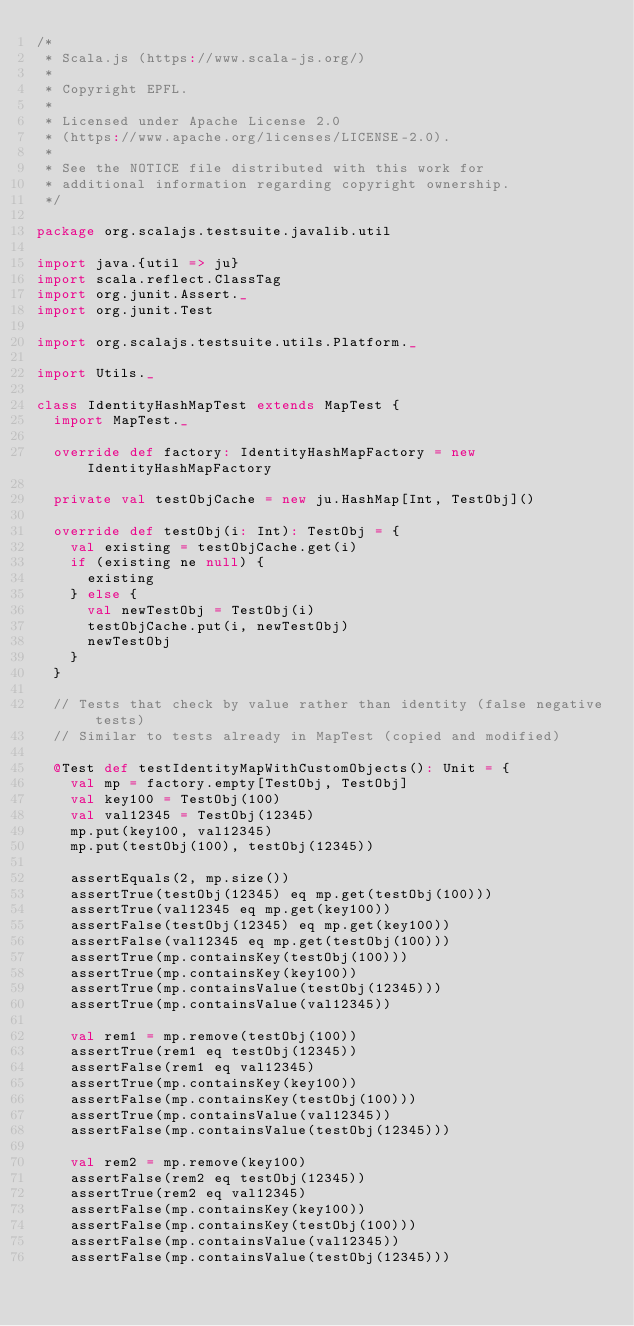<code> <loc_0><loc_0><loc_500><loc_500><_Scala_>/*
 * Scala.js (https://www.scala-js.org/)
 *
 * Copyright EPFL.
 *
 * Licensed under Apache License 2.0
 * (https://www.apache.org/licenses/LICENSE-2.0).
 *
 * See the NOTICE file distributed with this work for
 * additional information regarding copyright ownership.
 */

package org.scalajs.testsuite.javalib.util

import java.{util => ju}
import scala.reflect.ClassTag
import org.junit.Assert._
import org.junit.Test

import org.scalajs.testsuite.utils.Platform._

import Utils._

class IdentityHashMapTest extends MapTest {
  import MapTest._

  override def factory: IdentityHashMapFactory = new IdentityHashMapFactory

  private val testObjCache = new ju.HashMap[Int, TestObj]()

  override def testObj(i: Int): TestObj = {
    val existing = testObjCache.get(i)
    if (existing ne null) {
      existing
    } else {
      val newTestObj = TestObj(i)
      testObjCache.put(i, newTestObj)
      newTestObj
    }
  }

  // Tests that check by value rather than identity (false negative tests)
  // Similar to tests already in MapTest (copied and modified)

  @Test def testIdentityMapWithCustomObjects(): Unit = {
    val mp = factory.empty[TestObj, TestObj]
    val key100 = TestObj(100)
    val val12345 = TestObj(12345)
    mp.put(key100, val12345)
    mp.put(testObj(100), testObj(12345))

    assertEquals(2, mp.size())
    assertTrue(testObj(12345) eq mp.get(testObj(100)))
    assertTrue(val12345 eq mp.get(key100))
    assertFalse(testObj(12345) eq mp.get(key100))
    assertFalse(val12345 eq mp.get(testObj(100)))
    assertTrue(mp.containsKey(testObj(100)))
    assertTrue(mp.containsKey(key100))
    assertTrue(mp.containsValue(testObj(12345)))
    assertTrue(mp.containsValue(val12345))

    val rem1 = mp.remove(testObj(100))
    assertTrue(rem1 eq testObj(12345))
    assertFalse(rem1 eq val12345)
    assertTrue(mp.containsKey(key100))
    assertFalse(mp.containsKey(testObj(100)))
    assertTrue(mp.containsValue(val12345))
    assertFalse(mp.containsValue(testObj(12345)))

    val rem2 = mp.remove(key100)
    assertFalse(rem2 eq testObj(12345))
    assertTrue(rem2 eq val12345)
    assertFalse(mp.containsKey(key100))
    assertFalse(mp.containsKey(testObj(100)))
    assertFalse(mp.containsValue(val12345))
    assertFalse(mp.containsValue(testObj(12345)))</code> 